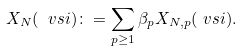<formula> <loc_0><loc_0><loc_500><loc_500>X _ { N } ( \ v s i ) & \colon = \sum _ { p \geq 1 } \beta _ { p } X _ { N , p } ( \ v s i ) .</formula> 